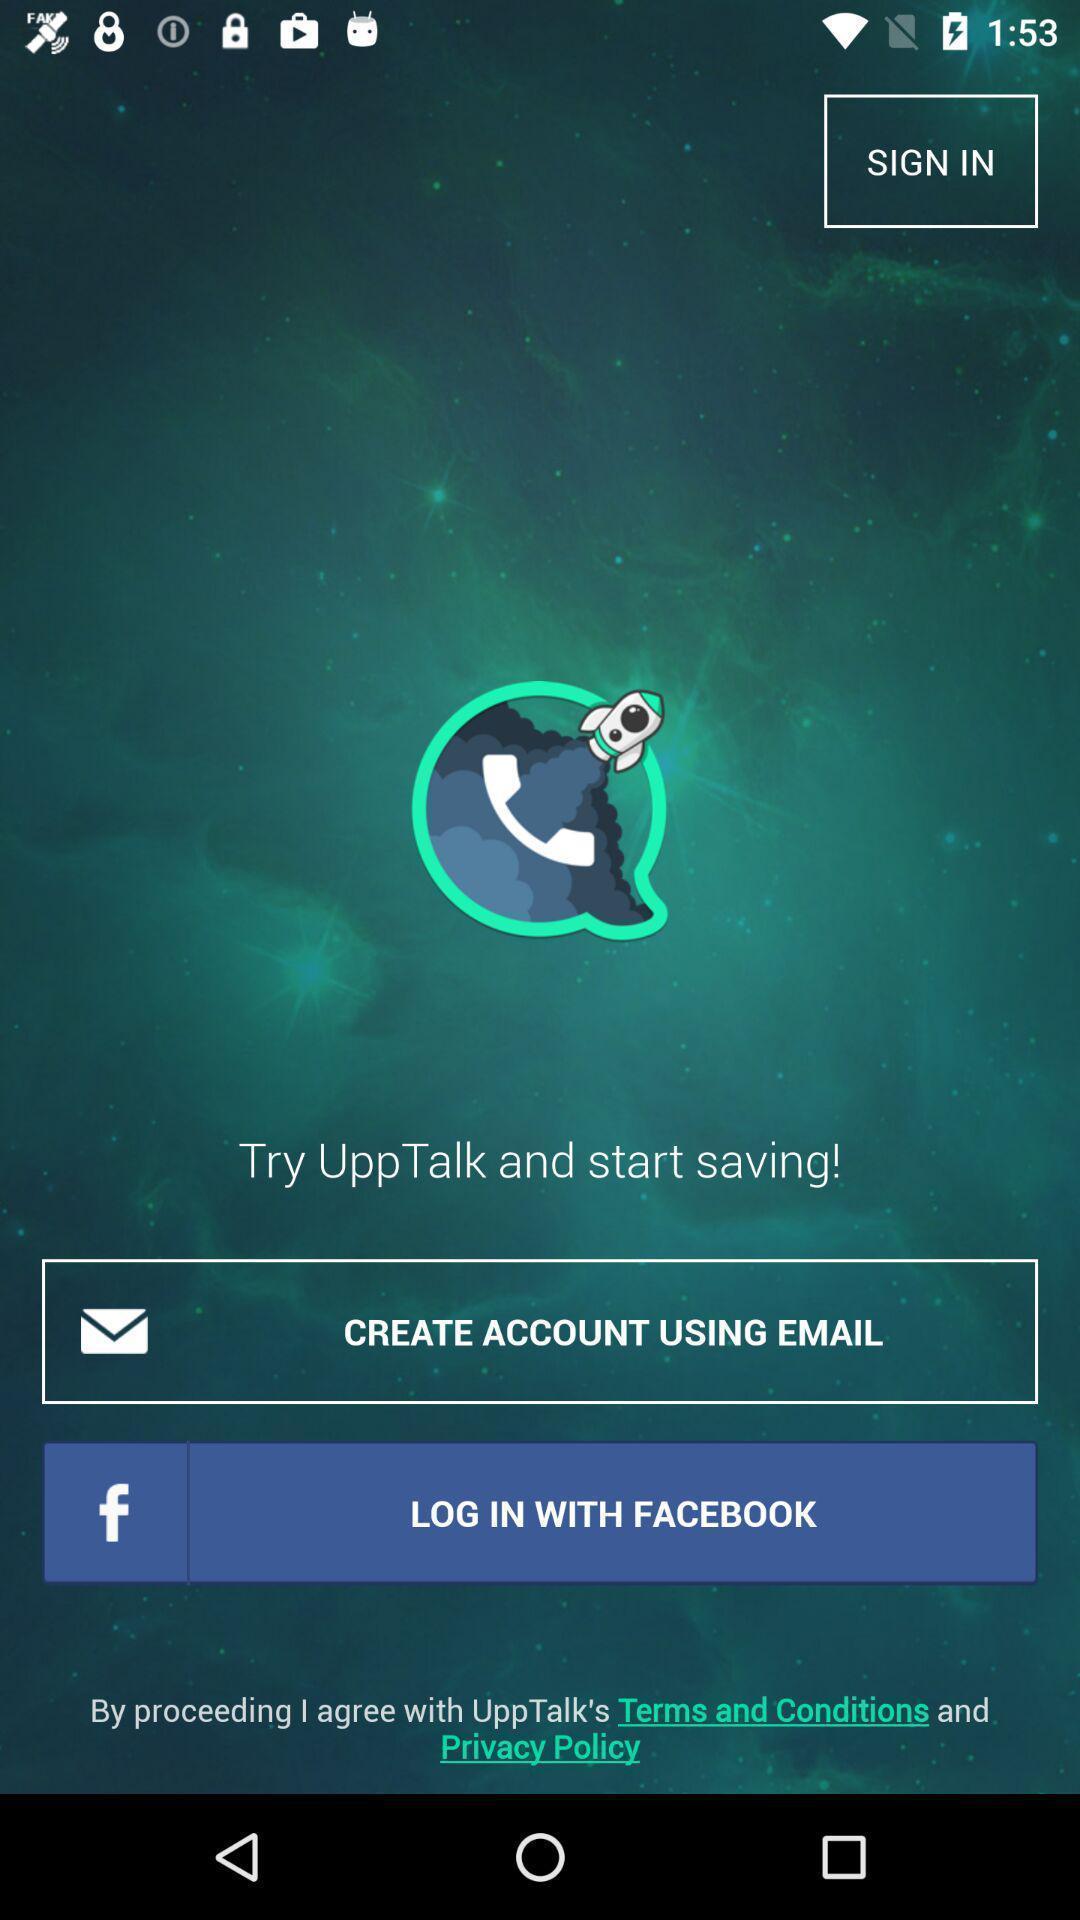Summarize the information in this screenshot. Welcome page for a voice communication based app. 